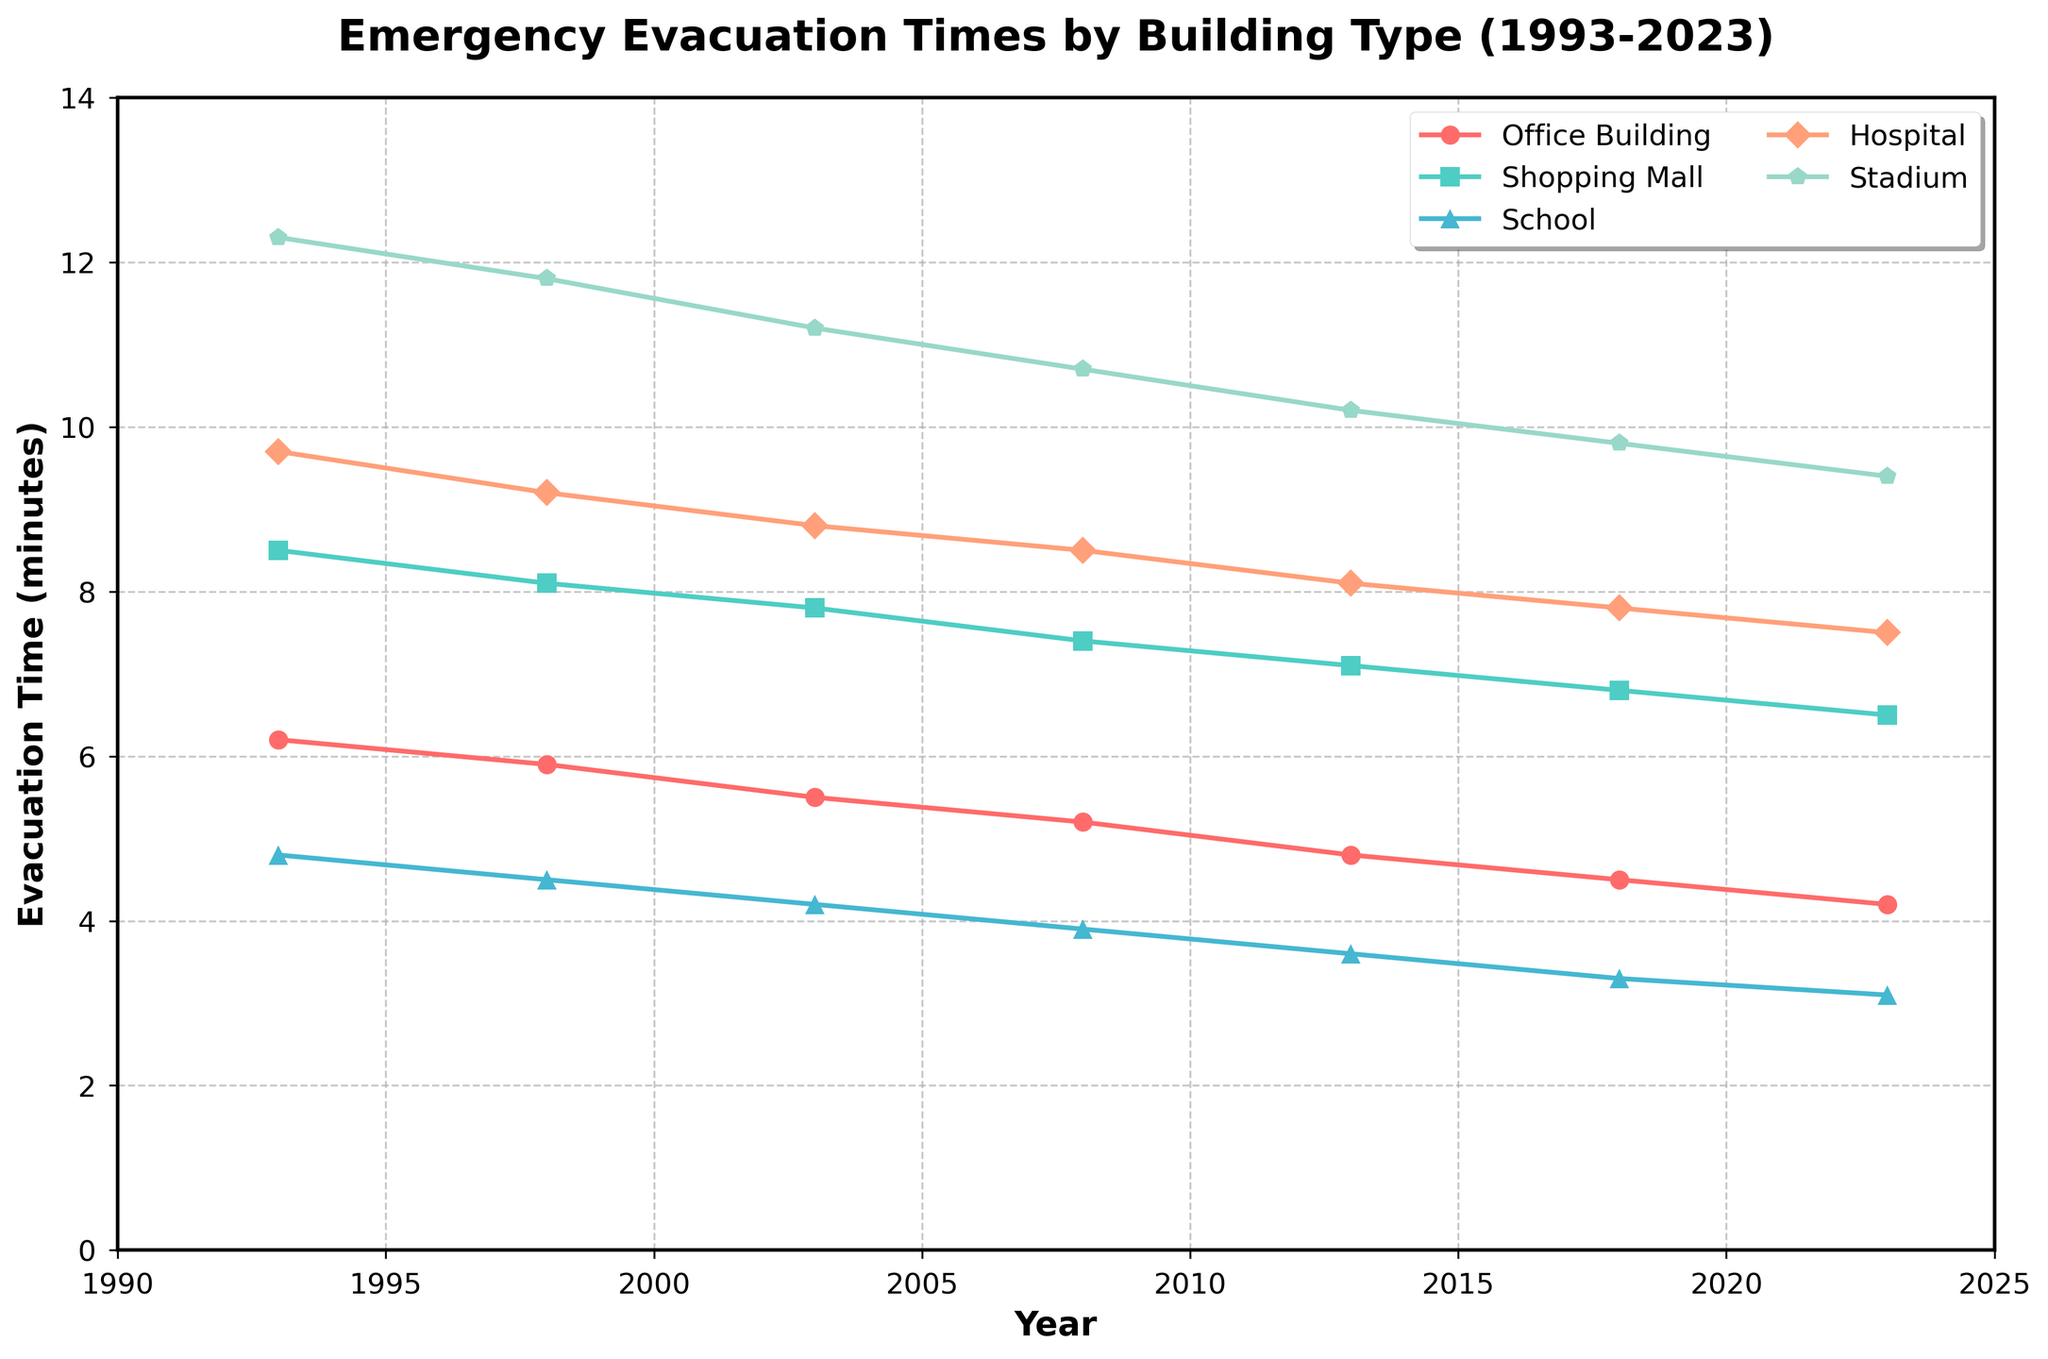What is the evacuation time trend for office buildings from 1993 to 2023? The evacuation time for office buildings consistently decreases over the 30 years. It starts at 6.2 minutes in 1993 and drops to 4.2 minutes in 2023.
Answer: The trend shows a consistent decrease Which building type had the highest evacuation time in 2023? By observing the 2023 data points, the stadium has the highest evacuation time, which is 9.4 minutes.
Answer: Stadium How does the evacuation time of shopping malls compare to schools in 2013? In 2013, the evacuation time for shopping malls is 7.1 minutes, while for schools, it is 3.6 minutes. Therefore, shopping malls have a longer evacuation time compared to schools.
Answer: Shopping malls have a longer evacuation time By how many minutes did the evacuation time for hospitals decrease from 1993 to 2023? In 1993, the evacuation time for hospitals was 9.7 minutes, and it decreased to 7.5 minutes in 2023. The difference is 9.7 - 7.5 = 2.2 minutes.
Answer: 2.2 minutes Which building type had the smallest decline in evacuation time from 1993 to 2023? We need to calculate the difference for each building type:
- Office Building: 6.2 - 4.2 = 2.0 minutes
- Shopping Mall: 8.5 - 6.5 = 2.0 minutes
- School: 4.8 - 3.1 = 1.7 minutes
- Hospital: 9.7 - 7.5 = 2.2 minutes
- Stadium: 12.3 - 9.4 = 2.9 minutes
The smallest decline is for schools with a decrease of 1.7 minutes.
Answer: School Which year saw the most significant decrease in evacuation time for office buildings? Looking at the given data:
- 1993 to 1998: 6.2 - 5.9 = 0.3 minutes
- 1998 to 2003: 5.9 - 5.5 = 0.4 minutes
- 2003 to 2008: 5.5 - 5.2 = 0.3 minutes
- 2008 to 2013: 5.2 - 4.8 = 0.4 minutes
- 2013 to 2018: 4.8 - 4.5 = 0.3 minutes
- 2018 to 2023: 4.5 - 4.2 = 0.3 minutes
The most significant decrease was 0.4 minutes between 1998 to 2003 and 2008 to 2013.
Answer: 1998-2003 and 2008-2013 What was the average evacuation time for all building types in 2003? Sum the evacuation times for each building type in 2003: 5.5 (Office Building) + 7.8 (Shopping Mall) + 4.2 (School) + 8.8 (Hospital) + 11.2 (Stadium) = 37.5 minutes. Divide by the number of building types: 37.5 / 5 = 7.5 minutes average.
Answer: 7.5 minutes How did the evacuation time for schools change from 1993 to 2023, both in percentage and in absolute value? In 1993, the evacuation time was 4.8 minutes, and by 2023, it decreased to 3.1 minutes. The absolute change is 4.8 - 3.1 = 1.7 minutes. To find the percentage change: (1.7 / 4.8) * 100 ≈ 35.42%.
Answer: 1.7 minutes decrease, approximately 35.42% What can you infer about the trend of emergency evacuation times across all building types depicted in the chart? The trend for all building types shows a decrease in evacuation times over the years from 1993 to 2023, indicating an overall improvement in evacuation efficiency.
Answer: Decreasing trend across all types 